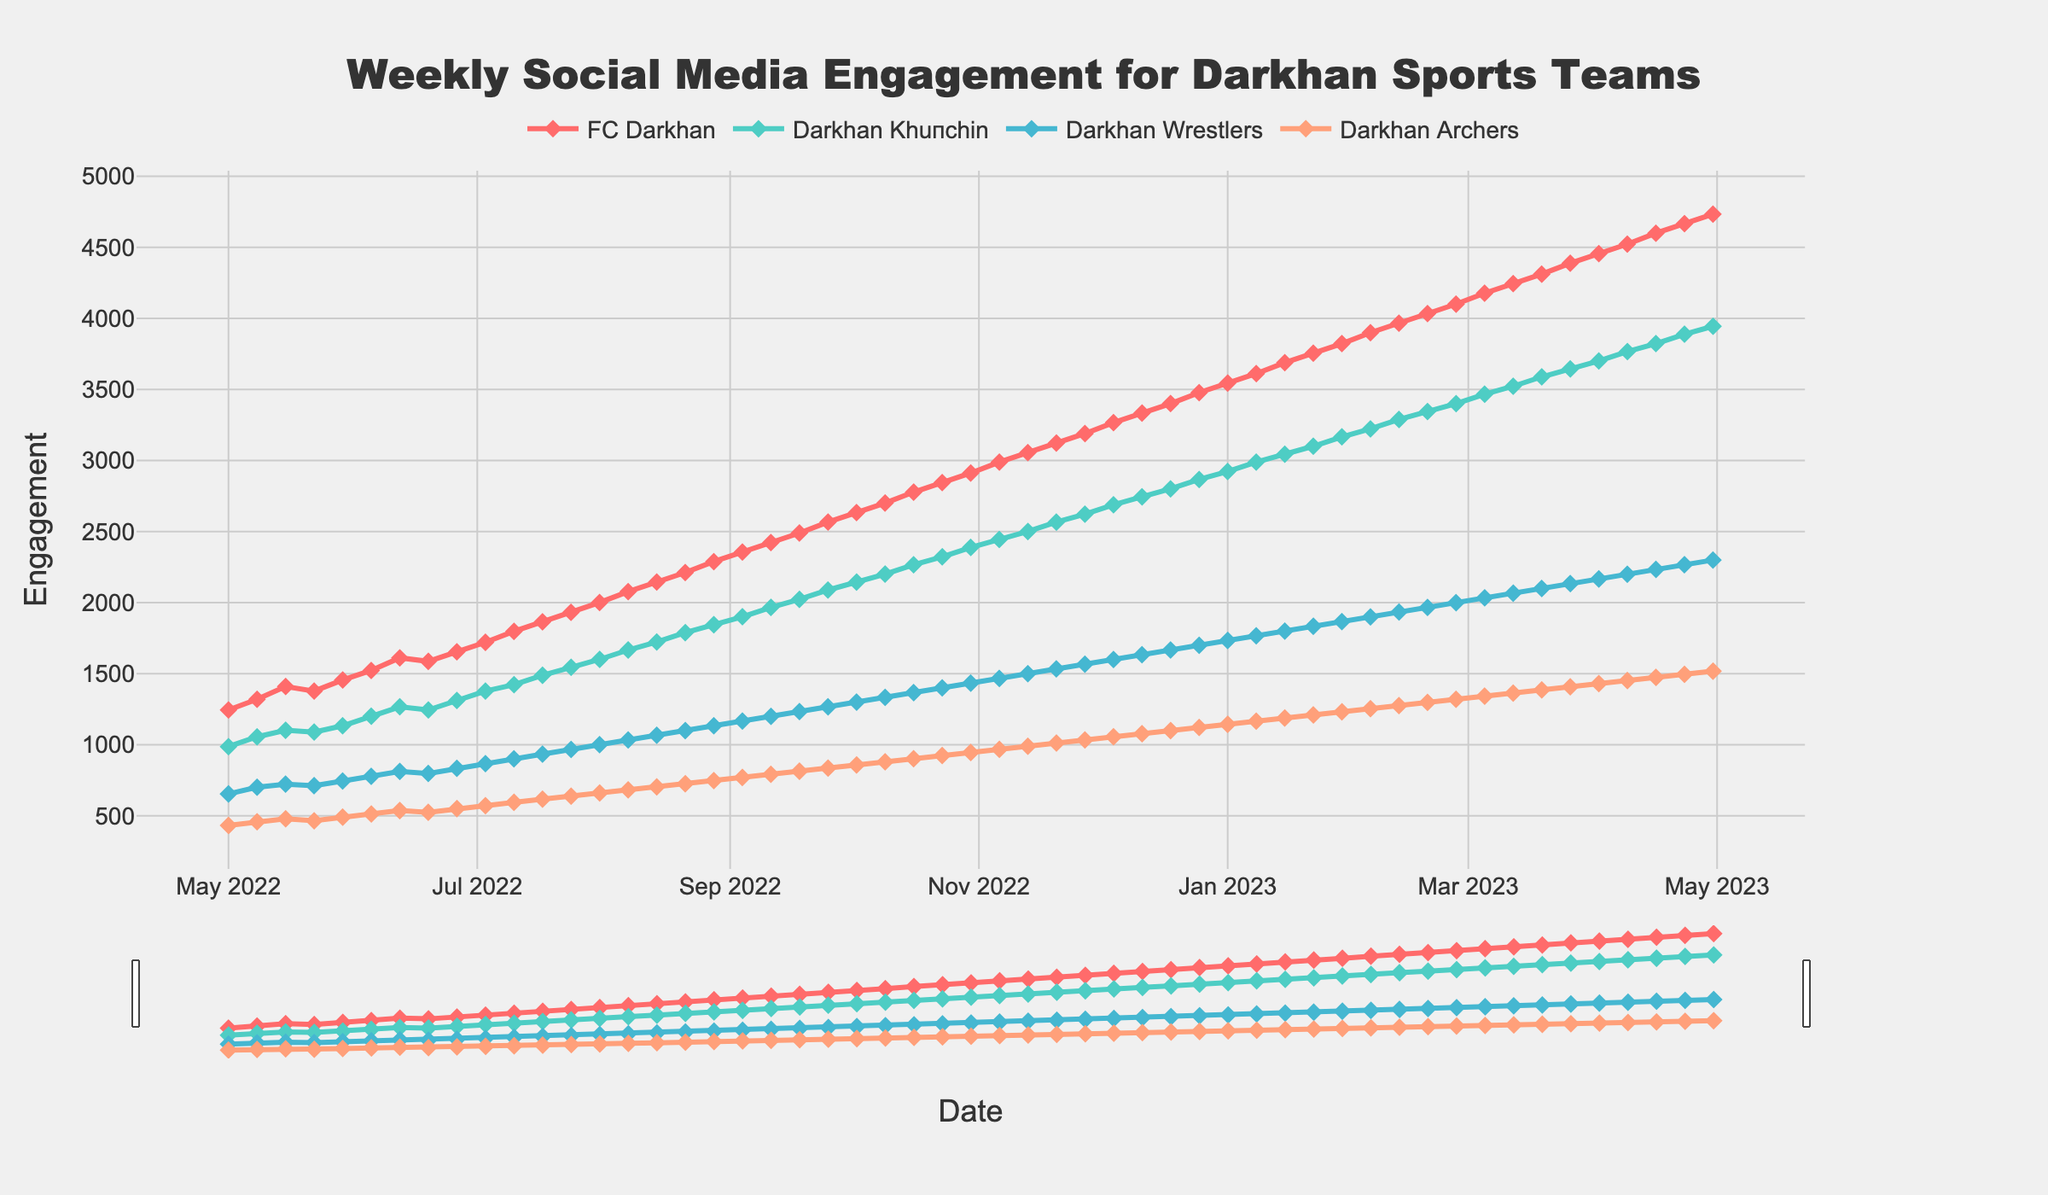What's the highest engagement level FC Darkhan reached? Look at the line corresponding to FC Darkhan and identify the peak value. FC Darkhan's highest point on the graph occurs in the last week with the value of 4734.
Answer: 4734 Which team had the lowest engagement level in the first week of data? Examine the first data point for each team on the graph. Darkhan Archers has the lowest value at the beginning of the series.
Answer: Darkhan Archers How does the engagement of FC Darkhan compare to Darkhan Khuпсhin on January 1st, 2023? Locate the points for FC Darkhan and Darkhan Khuпсhin on January 1st, 2023. FC Darkhan's engagement is 3545, and Darkhan Khuпсhin's is 2923. FC Darkhan's engagement is higher.
Answer: FC Darkhan is higher By how much did the engagement for Darkhan Wrestlers increase from May 1st, 2022 to March 26th, 2023? Check the values for Darkhan Wrestlers on May 1st, 2022 (654) and March 26th, 2023 (2134). Calculate the difference: 2134 - 654 = 1480.
Answer: 1480 What's the total engagement for all teams on July 31st, 2022? Sum the engagement values for all teams on July 31st, 2022 (2001 + 1601 + 1001 + 661): 2001 + 1601 + 1001 + 661 = 5264.
Answer: 5264 What is the trend in engagement for Darkhan Archers from December 2022 to March 2023? Observe the line for Darkhan Archers from December 2022 to March 2023. It starts at 1122 in December and climbs steadily to 1430 by early April, indicating an increasing trend.
Answer: Increasing Which team had the most significant engagement drop in any single week? Look for the steepest downward slope on any team's line. Darkhan Khuпсhin dropped from 987 to 1056, fewer drops were apparent, highlighting an overall increase trend in data. Hence, no significant drop is visually dominant.
Answer: No significant drop What's the engagement difference between Darkhan Wrestlers and Darkhan Archers on April 30th, 2023? Check the engagement values for both teams on April 30th, 2023: Darkhan Wrestlers (2300), and Darkhan Archers (1518). Calculate the difference: 2300 - 1518 = 782.
Answer: 782 During which month did FC Darkhan see the highest engagement growth? Observe the line for FC Darkhan and identify the month where the slope is steepest. The maximum growth seems to occur in March 2023 where the increment is highest.
Answer: March 2023 